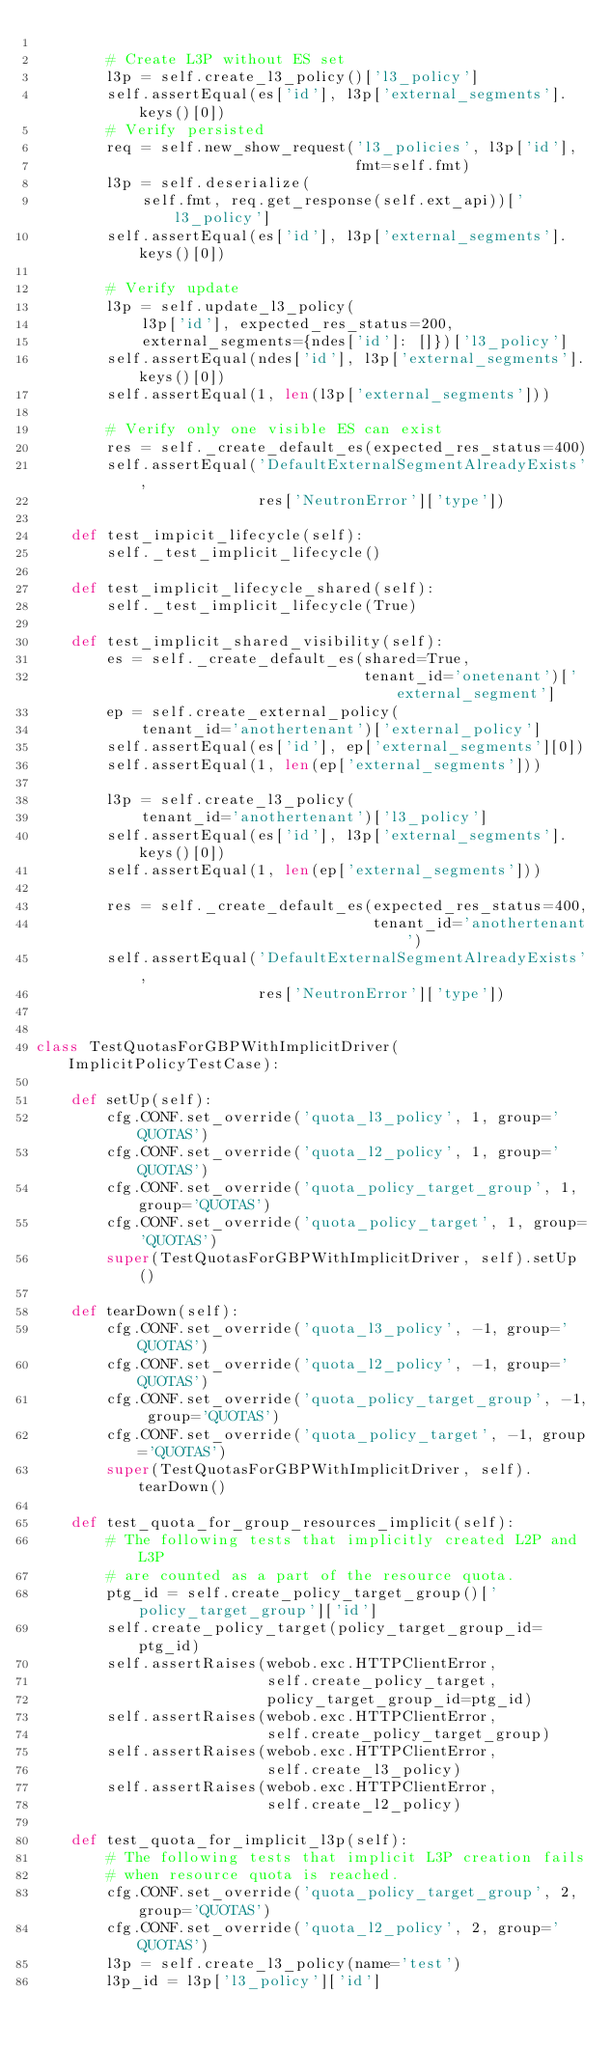Convert code to text. <code><loc_0><loc_0><loc_500><loc_500><_Python_>
        # Create L3P without ES set
        l3p = self.create_l3_policy()['l3_policy']
        self.assertEqual(es['id'], l3p['external_segments'].keys()[0])
        # Verify persisted
        req = self.new_show_request('l3_policies', l3p['id'],
                                    fmt=self.fmt)
        l3p = self.deserialize(
            self.fmt, req.get_response(self.ext_api))['l3_policy']
        self.assertEqual(es['id'], l3p['external_segments'].keys()[0])

        # Verify update
        l3p = self.update_l3_policy(
            l3p['id'], expected_res_status=200,
            external_segments={ndes['id']: []})['l3_policy']
        self.assertEqual(ndes['id'], l3p['external_segments'].keys()[0])
        self.assertEqual(1, len(l3p['external_segments']))

        # Verify only one visible ES can exist
        res = self._create_default_es(expected_res_status=400)
        self.assertEqual('DefaultExternalSegmentAlreadyExists',
                         res['NeutronError']['type'])

    def test_impicit_lifecycle(self):
        self._test_implicit_lifecycle()

    def test_implicit_lifecycle_shared(self):
        self._test_implicit_lifecycle(True)

    def test_implicit_shared_visibility(self):
        es = self._create_default_es(shared=True,
                                     tenant_id='onetenant')['external_segment']
        ep = self.create_external_policy(
            tenant_id='anothertenant')['external_policy']
        self.assertEqual(es['id'], ep['external_segments'][0])
        self.assertEqual(1, len(ep['external_segments']))

        l3p = self.create_l3_policy(
            tenant_id='anothertenant')['l3_policy']
        self.assertEqual(es['id'], l3p['external_segments'].keys()[0])
        self.assertEqual(1, len(ep['external_segments']))

        res = self._create_default_es(expected_res_status=400,
                                      tenant_id='anothertenant')
        self.assertEqual('DefaultExternalSegmentAlreadyExists',
                         res['NeutronError']['type'])


class TestQuotasForGBPWithImplicitDriver(ImplicitPolicyTestCase):

    def setUp(self):
        cfg.CONF.set_override('quota_l3_policy', 1, group='QUOTAS')
        cfg.CONF.set_override('quota_l2_policy', 1, group='QUOTAS')
        cfg.CONF.set_override('quota_policy_target_group', 1, group='QUOTAS')
        cfg.CONF.set_override('quota_policy_target', 1, group='QUOTAS')
        super(TestQuotasForGBPWithImplicitDriver, self).setUp()

    def tearDown(self):
        cfg.CONF.set_override('quota_l3_policy', -1, group='QUOTAS')
        cfg.CONF.set_override('quota_l2_policy', -1, group='QUOTAS')
        cfg.CONF.set_override('quota_policy_target_group', -1, group='QUOTAS')
        cfg.CONF.set_override('quota_policy_target', -1, group='QUOTAS')
        super(TestQuotasForGBPWithImplicitDriver, self).tearDown()

    def test_quota_for_group_resources_implicit(self):
        # The following tests that implicitly created L2P and L3P
        # are counted as a part of the resource quota.
        ptg_id = self.create_policy_target_group()['policy_target_group']['id']
        self.create_policy_target(policy_target_group_id=ptg_id)
        self.assertRaises(webob.exc.HTTPClientError,
                          self.create_policy_target,
                          policy_target_group_id=ptg_id)
        self.assertRaises(webob.exc.HTTPClientError,
                          self.create_policy_target_group)
        self.assertRaises(webob.exc.HTTPClientError,
                          self.create_l3_policy)
        self.assertRaises(webob.exc.HTTPClientError,
                          self.create_l2_policy)

    def test_quota_for_implicit_l3p(self):
        # The following tests that implicit L3P creation fails
        # when resource quota is reached.
        cfg.CONF.set_override('quota_policy_target_group', 2, group='QUOTAS')
        cfg.CONF.set_override('quota_l2_policy', 2, group='QUOTAS')
        l3p = self.create_l3_policy(name='test')
        l3p_id = l3p['l3_policy']['id']</code> 